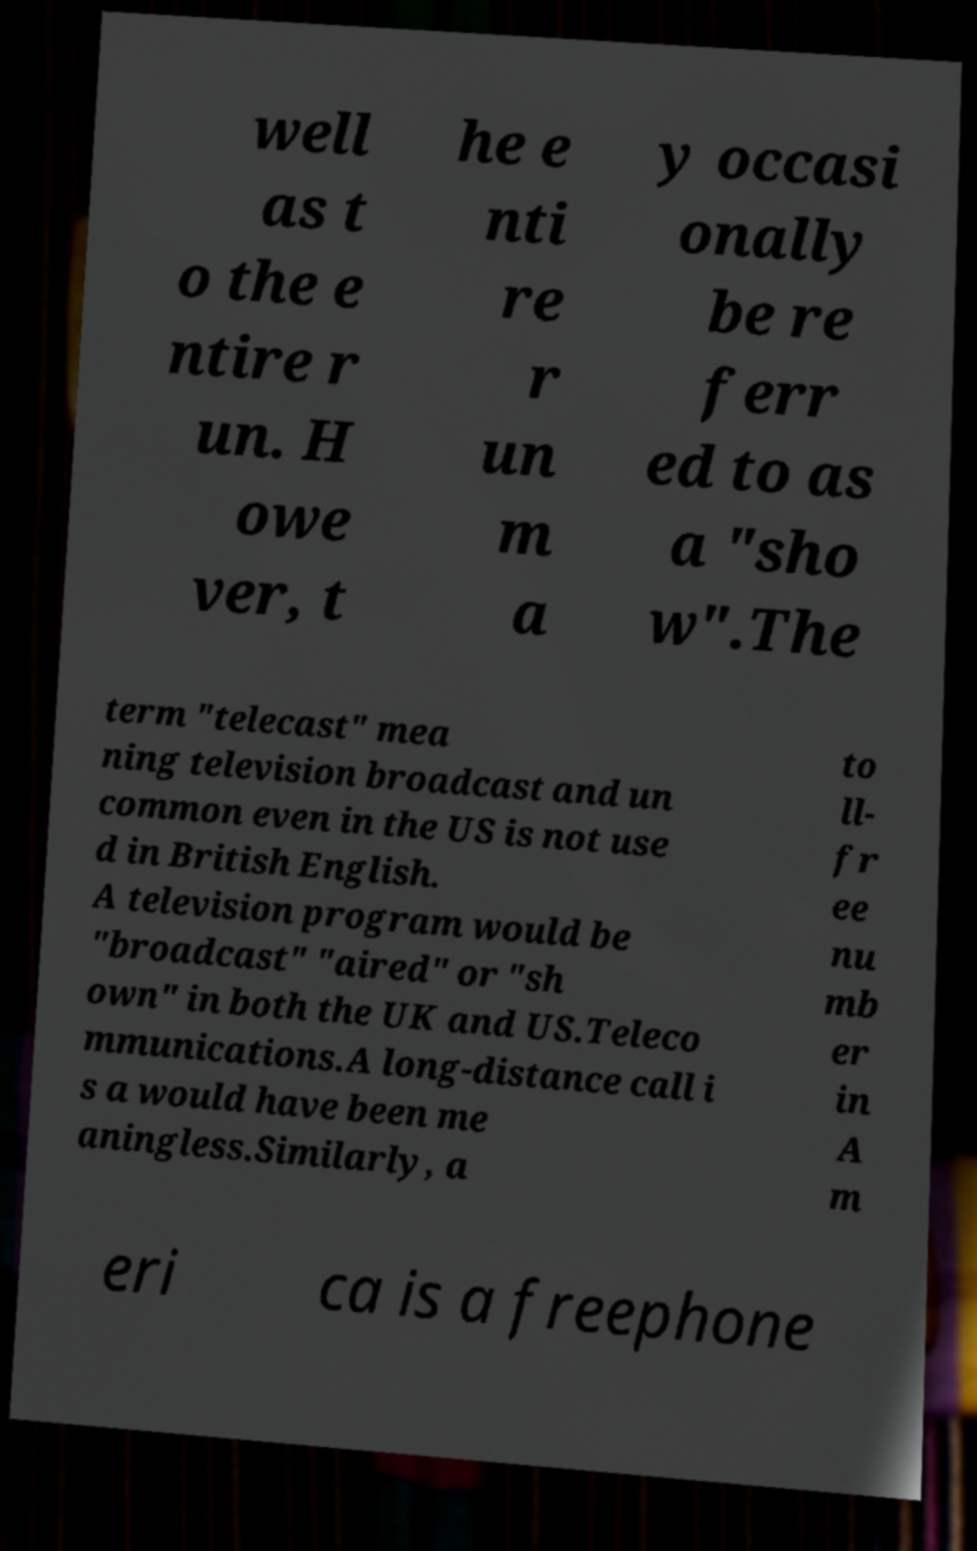Could you extract and type out the text from this image? well as t o the e ntire r un. H owe ver, t he e nti re r un m a y occasi onally be re ferr ed to as a "sho w".The term "telecast" mea ning television broadcast and un common even in the US is not use d in British English. A television program would be "broadcast" "aired" or "sh own" in both the UK and US.Teleco mmunications.A long-distance call i s a would have been me aningless.Similarly, a to ll- fr ee nu mb er in A m eri ca is a freephone 